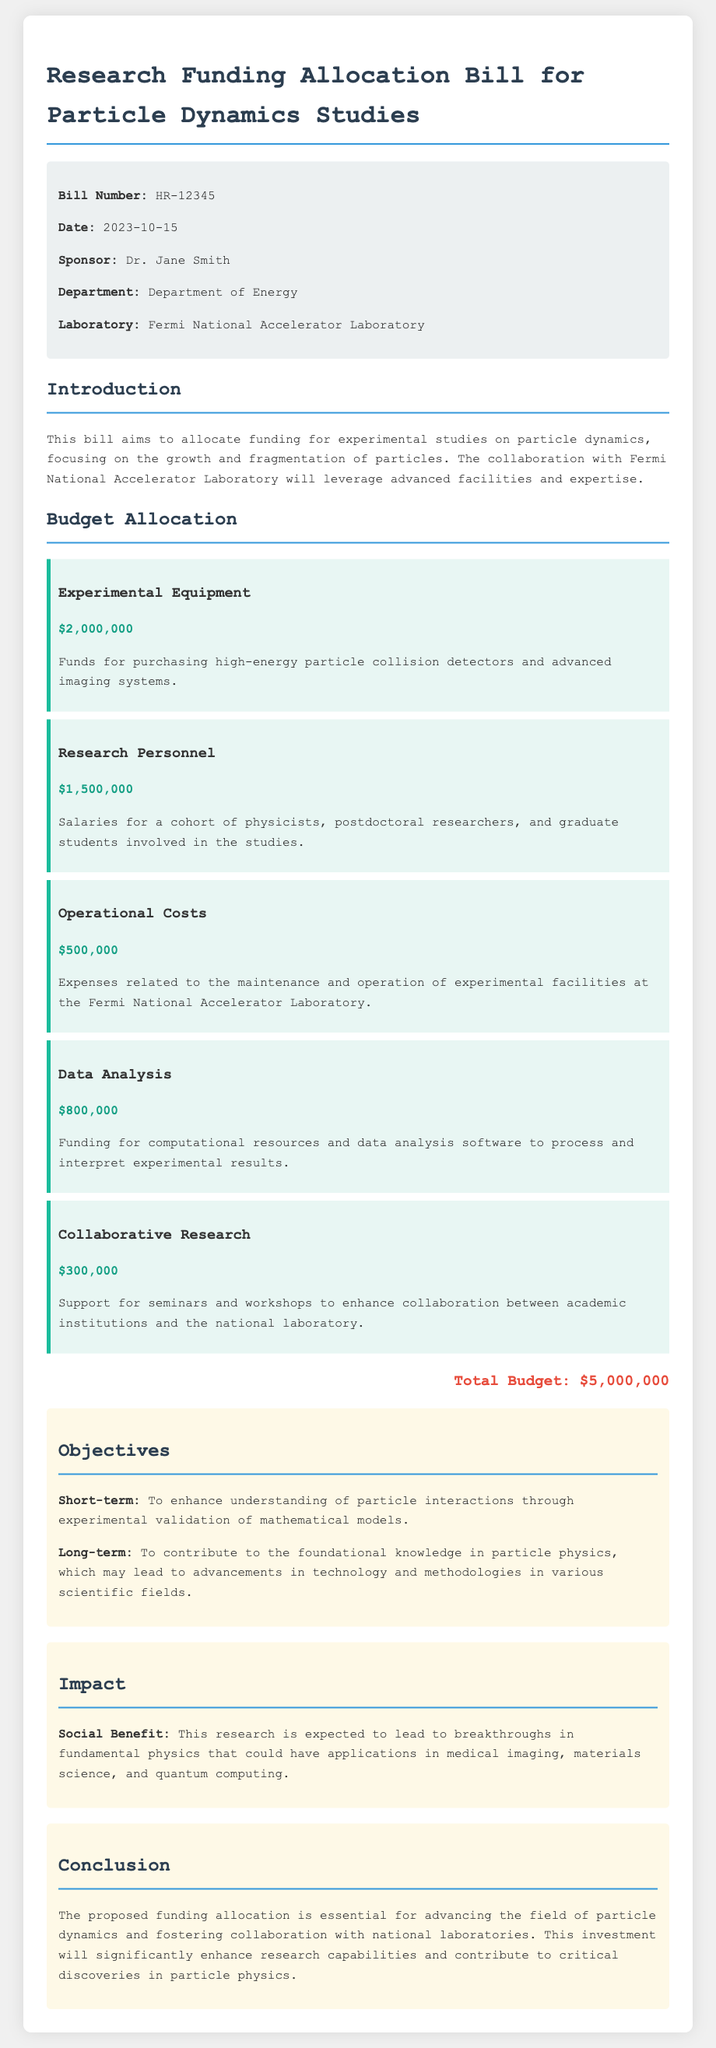What is the bill number? The bill number is specified in the document header as HR-12345.
Answer: HR-12345 Who is the sponsor of the bill? The sponsor is identified as Dr. Jane Smith in the document.
Answer: Dr. Jane Smith How much is allocated for experimental equipment? The budget allocation for experimental equipment is detailed in the document as $2,000,000.
Answer: $2,000,000 What is the total budget for the research funding allocation? The total budget is clearly stated at the end of the budget allocation section as $5,000,000.
Answer: $5,000,000 What is one short-term objective mentioned in the document? A short-term objective is noted as enhancing understanding of particle interactions through experimental validation.
Answer: Enhance understanding of particle interactions What is the amount allocated for data analysis? The document specifies that $800,000 is allocated for data analysis funding.
Answer: $800,000 What is mentioned as a social benefit of the research? The document describes breakthroughs in fundamental physics that could have applications as a social benefit.
Answer: Breakthroughs in fundamental physics What department is involved in the research funding allocation? The department involved is listed as the Department of Energy in the document.
Answer: Department of Energy 